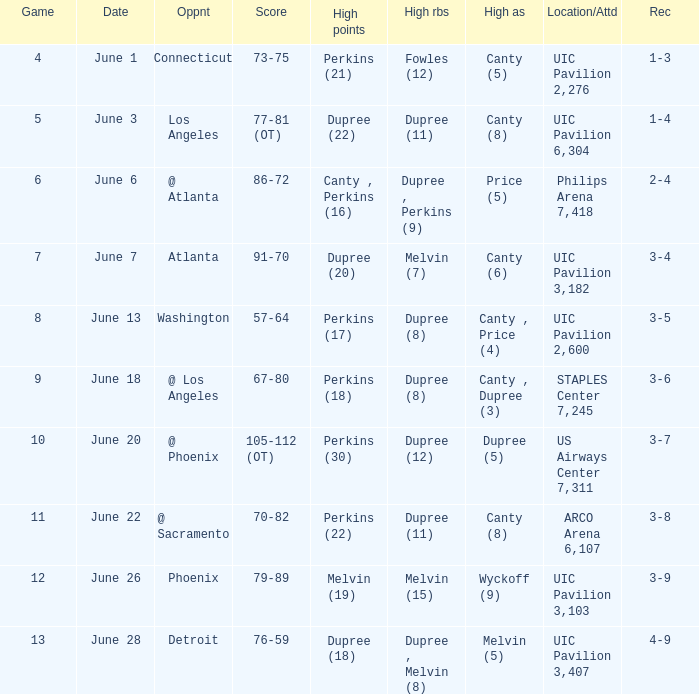What is the date of game 9? June 18. 